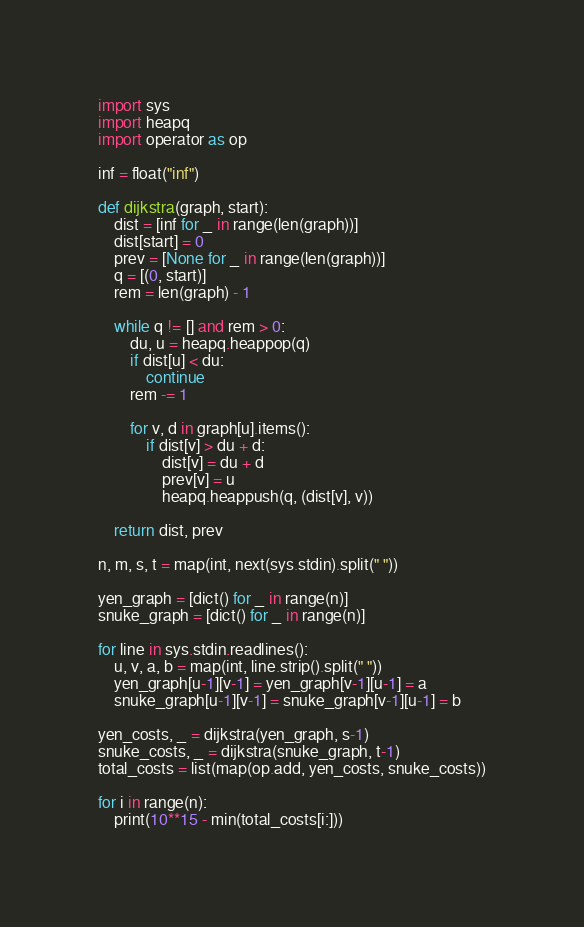Convert code to text. <code><loc_0><loc_0><loc_500><loc_500><_Python_>import sys
import heapq
import operator as op

inf = float("inf")

def dijkstra(graph, start):
    dist = [inf for _ in range(len(graph))]
    dist[start] = 0
    prev = [None for _ in range(len(graph))]
    q = [(0, start)]
    rem = len(graph) - 1

    while q != [] and rem > 0:
        du, u = heapq.heappop(q)
        if dist[u] < du:
            continue
        rem -= 1

        for v, d in graph[u].items():
            if dist[v] > du + d:
                dist[v] = du + d
                prev[v] = u
                heapq.heappush(q, (dist[v], v))

    return dist, prev

n, m, s, t = map(int, next(sys.stdin).split(" "))

yen_graph = [dict() for _ in range(n)]
snuke_graph = [dict() for _ in range(n)]

for line in sys.stdin.readlines():
    u, v, a, b = map(int, line.strip().split(" "))
    yen_graph[u-1][v-1] = yen_graph[v-1][u-1] = a
    snuke_graph[u-1][v-1] = snuke_graph[v-1][u-1] = b

yen_costs, _ = dijkstra(yen_graph, s-1)
snuke_costs, _ = dijkstra(snuke_graph, t-1)
total_costs = list(map(op.add, yen_costs, snuke_costs))

for i in range(n):
    print(10**15 - min(total_costs[i:]))
</code> 